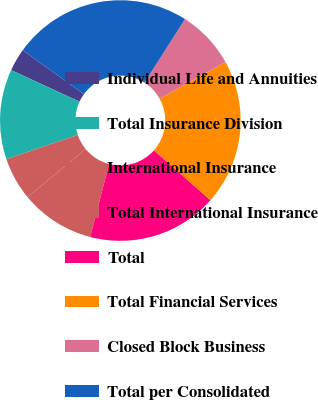Convert chart to OTSL. <chart><loc_0><loc_0><loc_500><loc_500><pie_chart><fcel>Individual Life and Annuities<fcel>Total Insurance Division<fcel>International Insurance<fcel>Total International Insurance<fcel>Total<fcel>Total Financial Services<fcel>Closed Block Business<fcel>Total per Consolidated<nl><fcel>3.05%<fcel>12.09%<fcel>5.77%<fcel>9.99%<fcel>17.51%<fcel>19.61%<fcel>7.88%<fcel>24.1%<nl></chart> 